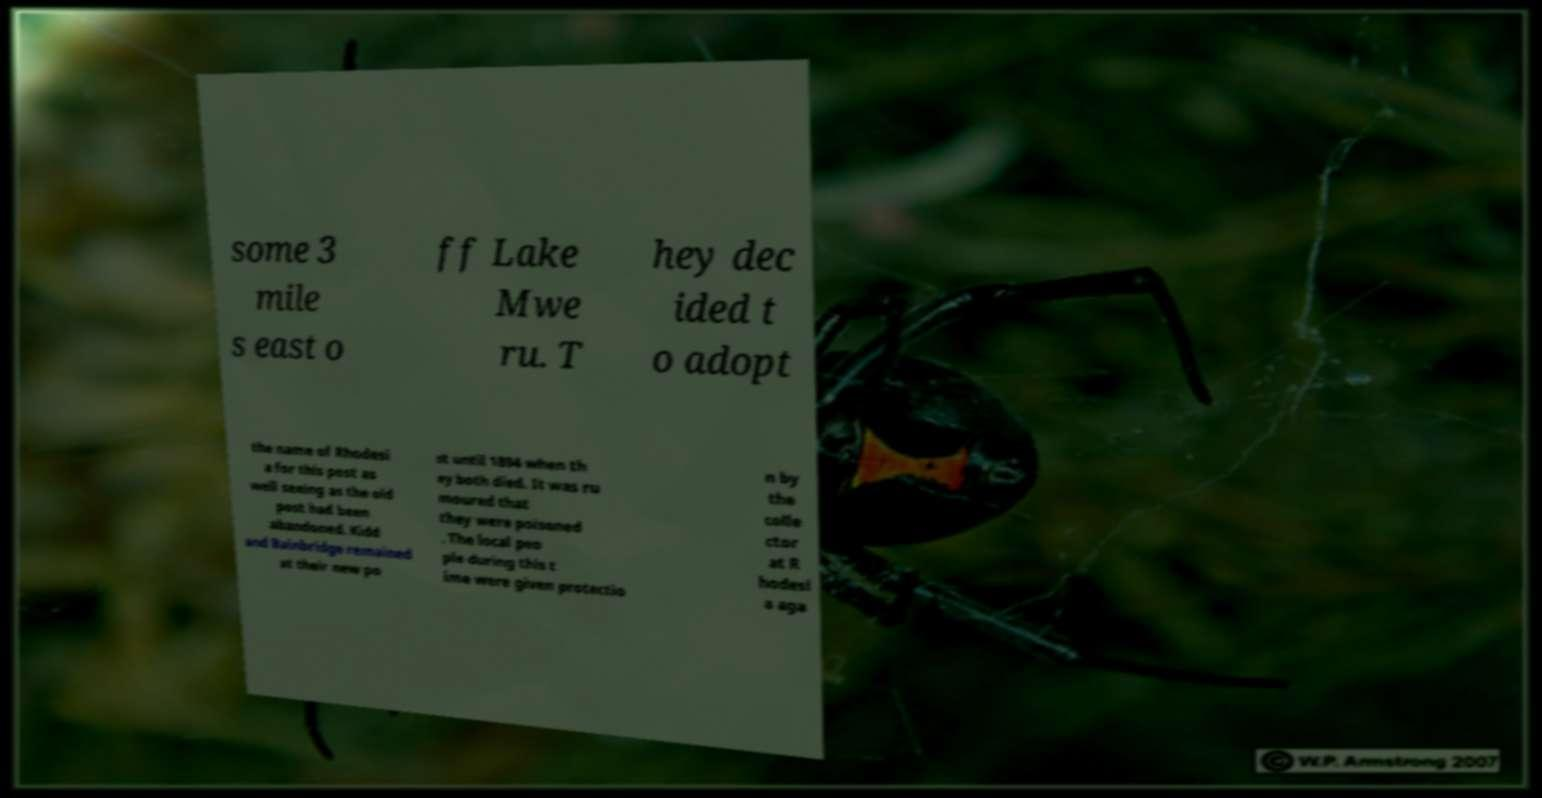There's text embedded in this image that I need extracted. Can you transcribe it verbatim? some 3 mile s east o ff Lake Mwe ru. T hey dec ided t o adopt the name of Rhodesi a for this post as well seeing as the old post had been abandoned. Kidd and Bainbridge remained at their new po st until 1894 when th ey both died. It was ru moured that they were poisoned . The local peo ple during this t ime were given protectio n by the colle ctor at R hodesi a aga 